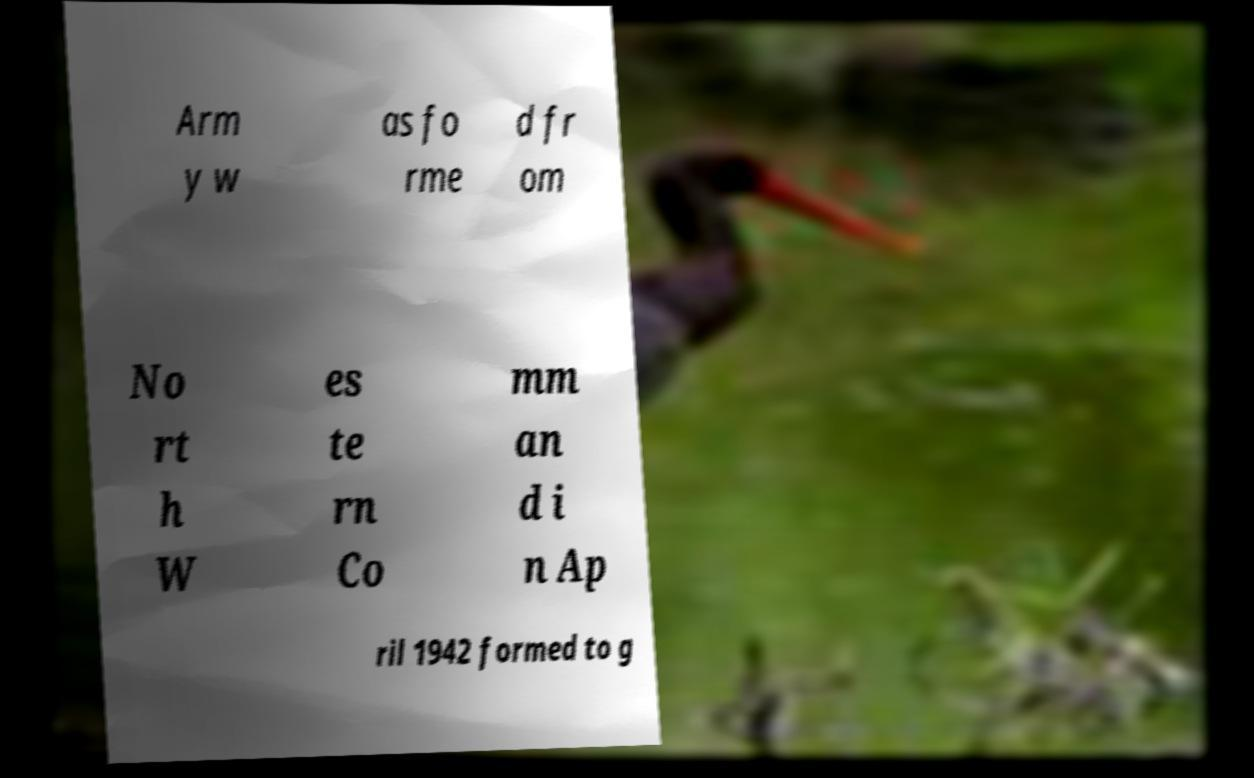For documentation purposes, I need the text within this image transcribed. Could you provide that? Arm y w as fo rme d fr om No rt h W es te rn Co mm an d i n Ap ril 1942 formed to g 